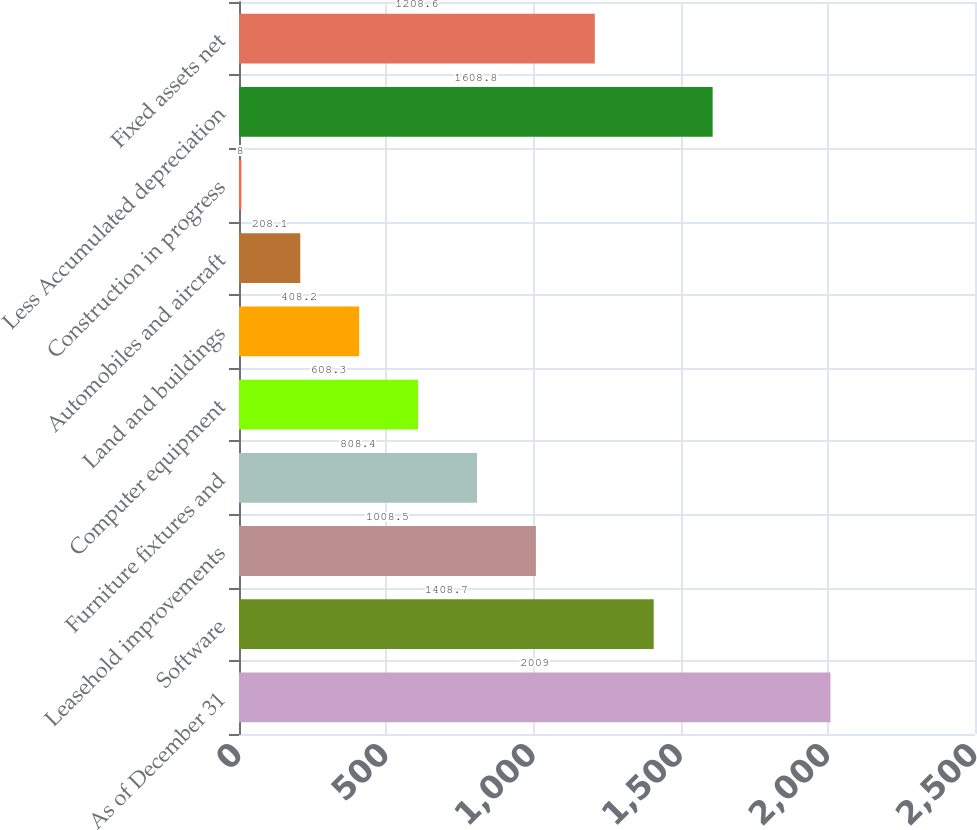Convert chart. <chart><loc_0><loc_0><loc_500><loc_500><bar_chart><fcel>As of December 31<fcel>Software<fcel>Leasehold improvements<fcel>Furniture fixtures and<fcel>Computer equipment<fcel>Land and buildings<fcel>Automobiles and aircraft<fcel>Construction in progress<fcel>Less Accumulated depreciation<fcel>Fixed assets net<nl><fcel>2009<fcel>1408.7<fcel>1008.5<fcel>808.4<fcel>608.3<fcel>408.2<fcel>208.1<fcel>8<fcel>1608.8<fcel>1208.6<nl></chart> 